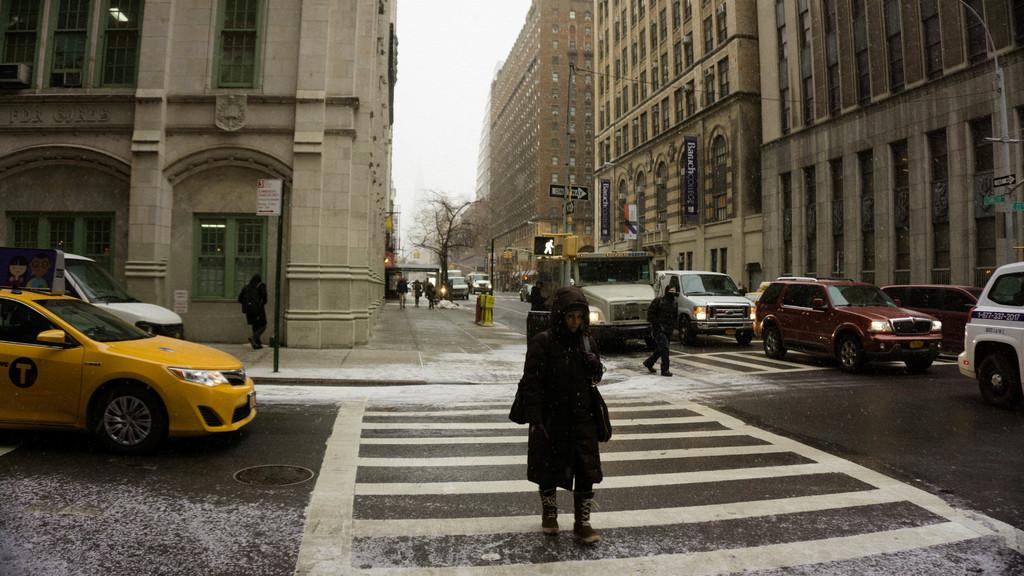What type of structures can be seen in the image? There are buildings in the image. Who or what else is present in the image? There are people and cars in the image. What type of vegetation is visible in the image? There is a tree in the image. What is visible at the top of the image? The sky is visible at the top of the image. What type of baseball can be seen in the image? There is no baseball present in the image. What is the purpose of the light in the image? There is no mention of a light in the image, so it is not possible to determine its purpose. 